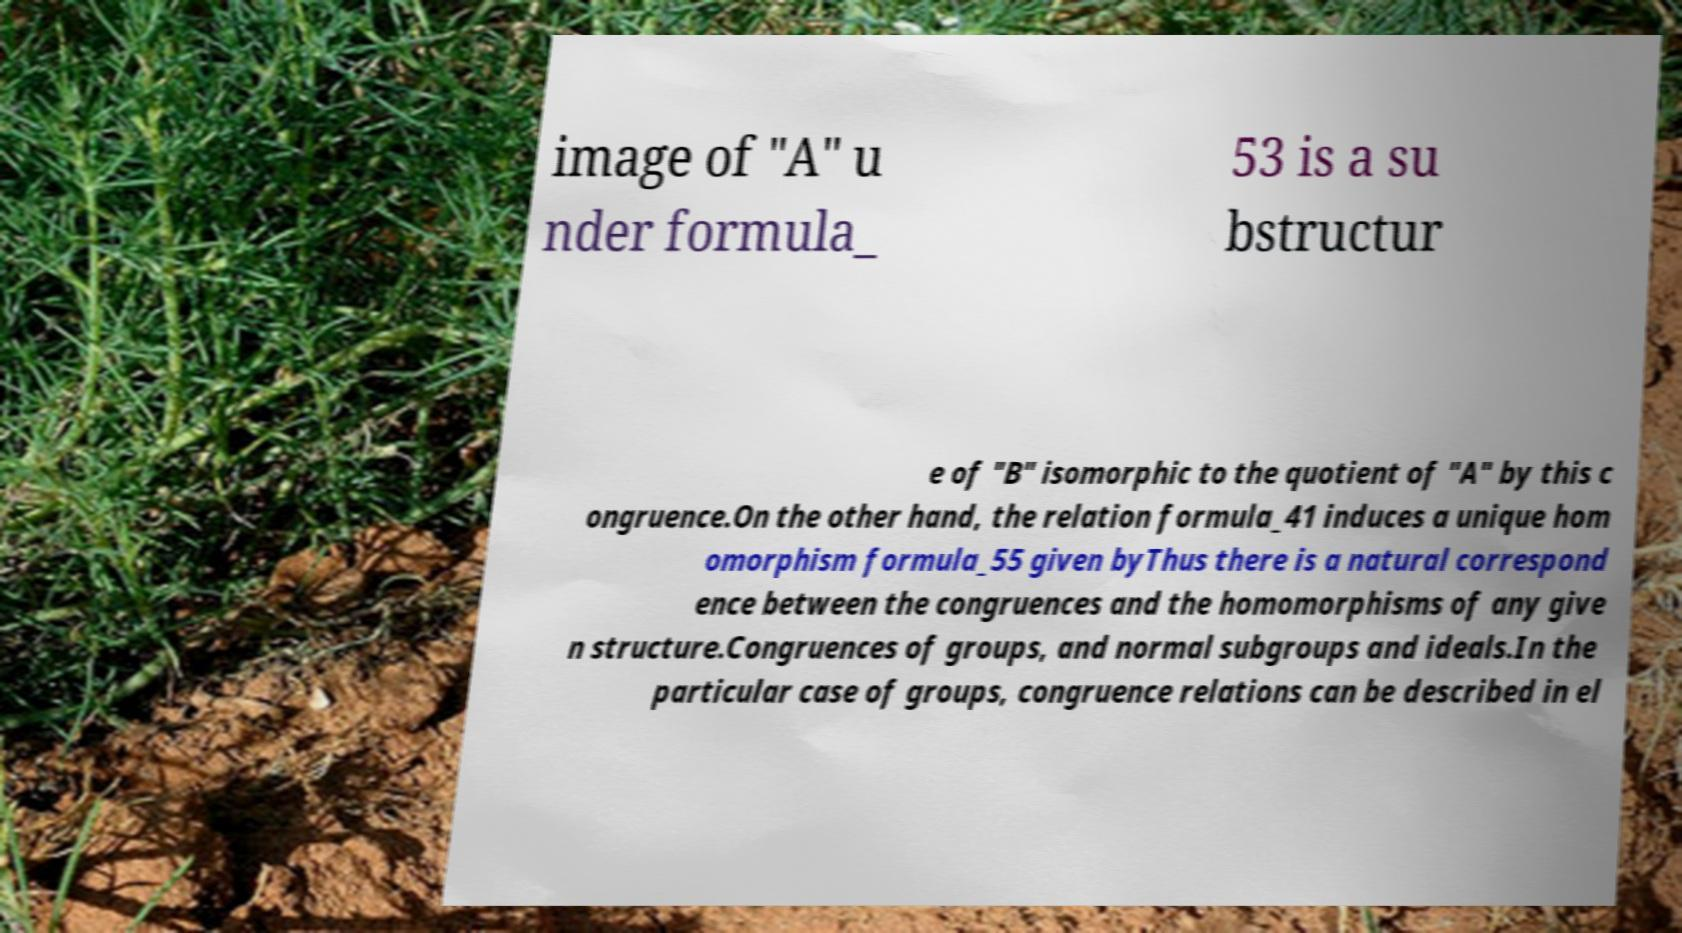Could you extract and type out the text from this image? image of "A" u nder formula_ 53 is a su bstructur e of "B" isomorphic to the quotient of "A" by this c ongruence.On the other hand, the relation formula_41 induces a unique hom omorphism formula_55 given byThus there is a natural correspond ence between the congruences and the homomorphisms of any give n structure.Congruences of groups, and normal subgroups and ideals.In the particular case of groups, congruence relations can be described in el 